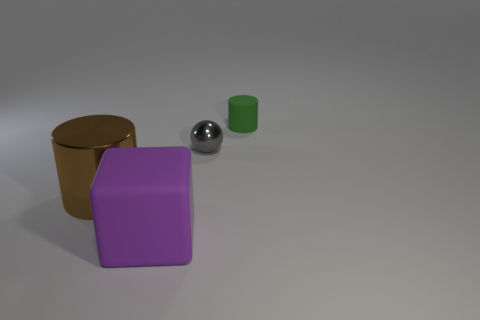Is the number of brown objects less than the number of shiny objects?
Give a very brief answer. Yes. Are there an equal number of small rubber cylinders behind the gray metal object and green cylinders that are left of the tiny green rubber cylinder?
Keep it short and to the point. No. What number of brown objects have the same shape as the purple rubber thing?
Offer a terse response. 0. Is there a big brown metal object?
Keep it short and to the point. Yes. Is the material of the gray ball the same as the cylinder right of the small sphere?
Offer a very short reply. No. What is the material of the green object that is the same size as the sphere?
Offer a terse response. Rubber. Are there any big purple things that have the same material as the green cylinder?
Provide a short and direct response. Yes. Is there a large brown metal object that is in front of the matte object that is behind the large object in front of the big brown metallic object?
Keep it short and to the point. Yes. The brown thing that is the same size as the purple block is what shape?
Ensure brevity in your answer.  Cylinder. Is the size of the cylinder to the left of the green cylinder the same as the cylinder behind the brown object?
Your answer should be compact. No. 